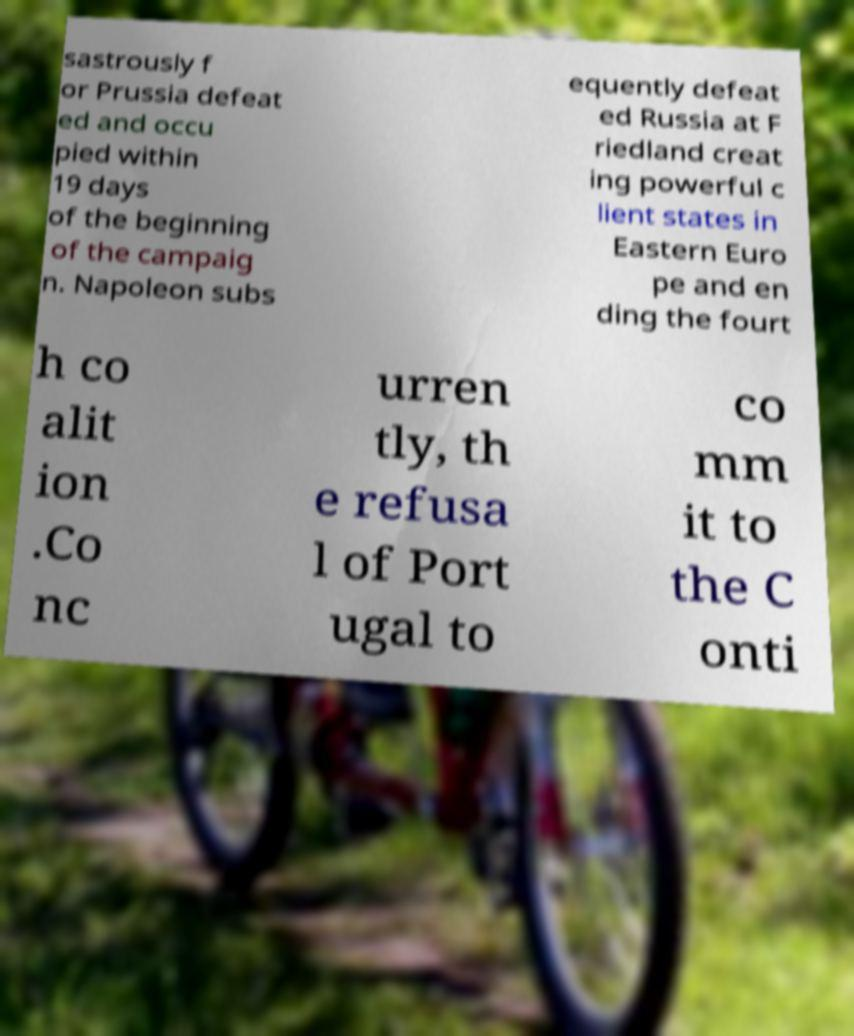Could you extract and type out the text from this image? sastrously f or Prussia defeat ed and occu pied within 19 days of the beginning of the campaig n. Napoleon subs equently defeat ed Russia at F riedland creat ing powerful c lient states in Eastern Euro pe and en ding the fourt h co alit ion .Co nc urren tly, th e refusa l of Port ugal to co mm it to the C onti 